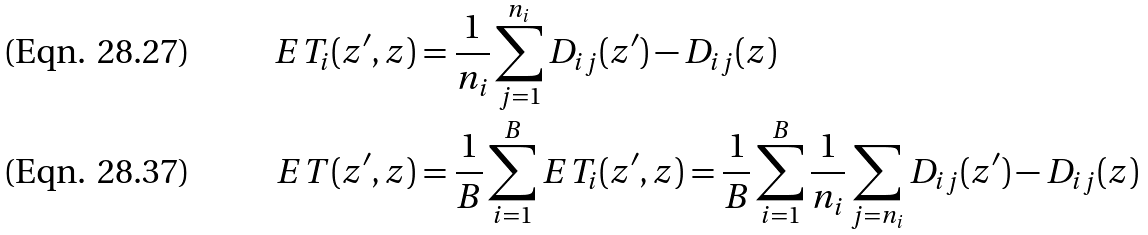<formula> <loc_0><loc_0><loc_500><loc_500>E T _ { i } ( z ^ { \prime } , z ) & = \frac { 1 } { n _ { i } } \sum _ { j = 1 } ^ { n _ { i } } D _ { i j } ( z ^ { \prime } ) - D _ { i j } ( z ) \\ E T ( z ^ { \prime } , z ) & = \frac { 1 } { B } \sum _ { i = 1 } ^ { B } E T _ { i } ( z ^ { \prime } , z ) = \frac { 1 } { B } \sum _ { i = 1 } ^ { B } \frac { 1 } { n _ { i } } \sum _ { j = n _ { i } } D _ { i j } ( z ^ { \prime } ) - D _ { i j } ( z )</formula> 